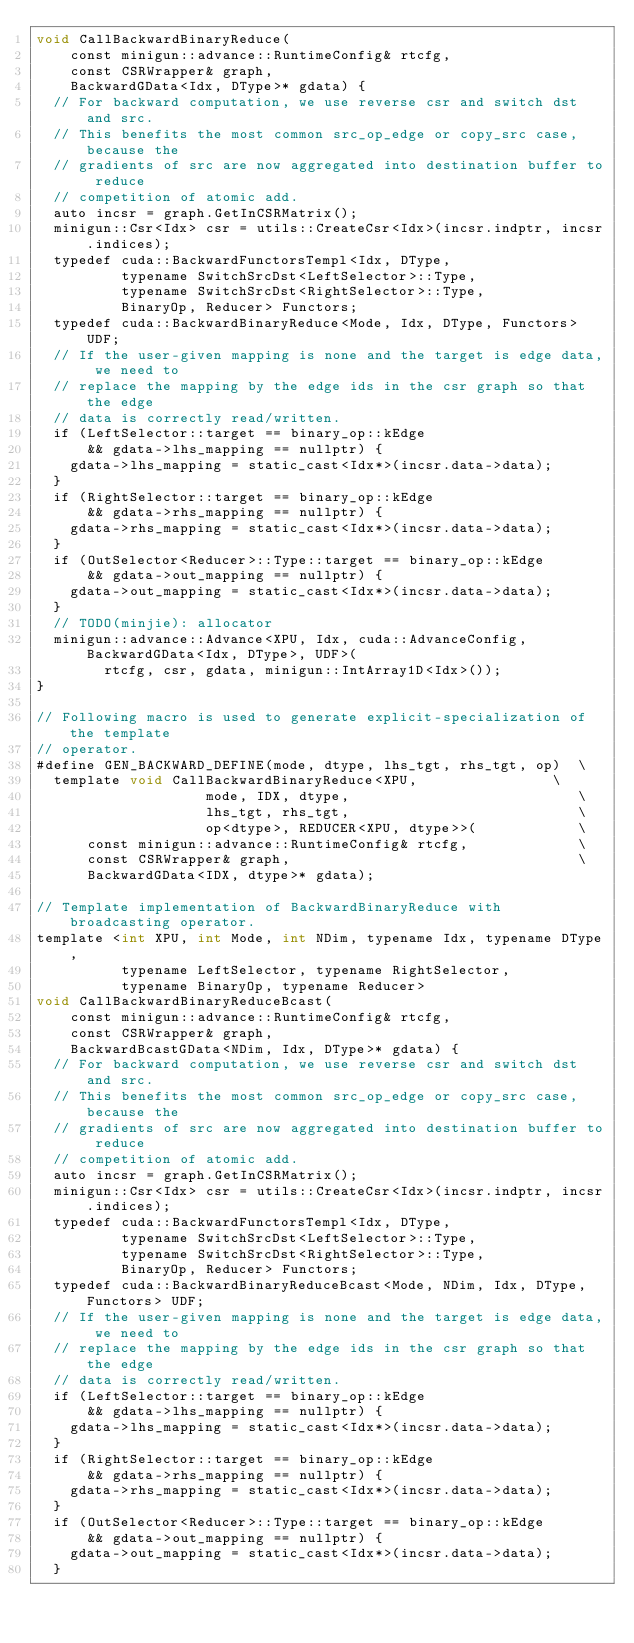Convert code to text. <code><loc_0><loc_0><loc_500><loc_500><_Cuda_>void CallBackwardBinaryReduce(
    const minigun::advance::RuntimeConfig& rtcfg,
    const CSRWrapper& graph,
    BackwardGData<Idx, DType>* gdata) {
  // For backward computation, we use reverse csr and switch dst and src.
  // This benefits the most common src_op_edge or copy_src case, because the
  // gradients of src are now aggregated into destination buffer to reduce
  // competition of atomic add.
  auto incsr = graph.GetInCSRMatrix();
  minigun::Csr<Idx> csr = utils::CreateCsr<Idx>(incsr.indptr, incsr.indices);
  typedef cuda::BackwardFunctorsTempl<Idx, DType,
          typename SwitchSrcDst<LeftSelector>::Type,
          typename SwitchSrcDst<RightSelector>::Type,
          BinaryOp, Reducer> Functors;
  typedef cuda::BackwardBinaryReduce<Mode, Idx, DType, Functors> UDF;
  // If the user-given mapping is none and the target is edge data, we need to
  // replace the mapping by the edge ids in the csr graph so that the edge
  // data is correctly read/written.
  if (LeftSelector::target == binary_op::kEdge
      && gdata->lhs_mapping == nullptr) {
    gdata->lhs_mapping = static_cast<Idx*>(incsr.data->data);
  }
  if (RightSelector::target == binary_op::kEdge
      && gdata->rhs_mapping == nullptr) {
    gdata->rhs_mapping = static_cast<Idx*>(incsr.data->data);
  }
  if (OutSelector<Reducer>::Type::target == binary_op::kEdge
      && gdata->out_mapping == nullptr) {
    gdata->out_mapping = static_cast<Idx*>(incsr.data->data);
  }
  // TODO(minjie): allocator
  minigun::advance::Advance<XPU, Idx, cuda::AdvanceConfig, BackwardGData<Idx, DType>, UDF>(
        rtcfg, csr, gdata, minigun::IntArray1D<Idx>());
}

// Following macro is used to generate explicit-specialization of the template
// operator.
#define GEN_BACKWARD_DEFINE(mode, dtype, lhs_tgt, rhs_tgt, op)  \
  template void CallBackwardBinaryReduce<XPU,                \
                    mode, IDX, dtype,                           \
                    lhs_tgt, rhs_tgt,                           \
                    op<dtype>, REDUCER<XPU, dtype>>(            \
      const minigun::advance::RuntimeConfig& rtcfg,             \
      const CSRWrapper& graph,                                  \
      BackwardGData<IDX, dtype>* gdata);

// Template implementation of BackwardBinaryReduce with broadcasting operator.
template <int XPU, int Mode, int NDim, typename Idx, typename DType,
          typename LeftSelector, typename RightSelector,
          typename BinaryOp, typename Reducer>
void CallBackwardBinaryReduceBcast(
    const minigun::advance::RuntimeConfig& rtcfg,
    const CSRWrapper& graph,
    BackwardBcastGData<NDim, Idx, DType>* gdata) {
  // For backward computation, we use reverse csr and switch dst and src.
  // This benefits the most common src_op_edge or copy_src case, because the
  // gradients of src are now aggregated into destination buffer to reduce
  // competition of atomic add.
  auto incsr = graph.GetInCSRMatrix();
  minigun::Csr<Idx> csr = utils::CreateCsr<Idx>(incsr.indptr, incsr.indices);
  typedef cuda::BackwardFunctorsTempl<Idx, DType,
          typename SwitchSrcDst<LeftSelector>::Type,
          typename SwitchSrcDst<RightSelector>::Type,
          BinaryOp, Reducer> Functors;
  typedef cuda::BackwardBinaryReduceBcast<Mode, NDim, Idx, DType, Functors> UDF;
  // If the user-given mapping is none and the target is edge data, we need to
  // replace the mapping by the edge ids in the csr graph so that the edge
  // data is correctly read/written.
  if (LeftSelector::target == binary_op::kEdge
      && gdata->lhs_mapping == nullptr) {
    gdata->lhs_mapping = static_cast<Idx*>(incsr.data->data);
  }
  if (RightSelector::target == binary_op::kEdge
      && gdata->rhs_mapping == nullptr) {
    gdata->rhs_mapping = static_cast<Idx*>(incsr.data->data);
  }
  if (OutSelector<Reducer>::Type::target == binary_op::kEdge
      && gdata->out_mapping == nullptr) {
    gdata->out_mapping = static_cast<Idx*>(incsr.data->data);
  }</code> 